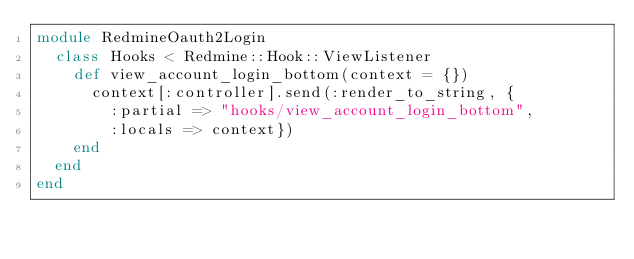Convert code to text. <code><loc_0><loc_0><loc_500><loc_500><_Ruby_>module RedmineOauth2Login
  class Hooks < Redmine::Hook::ViewListener
    def view_account_login_bottom(context = {})
      context[:controller].send(:render_to_string, {
        :partial => "hooks/view_account_login_bottom",
        :locals => context})
    end
  end
end
</code> 